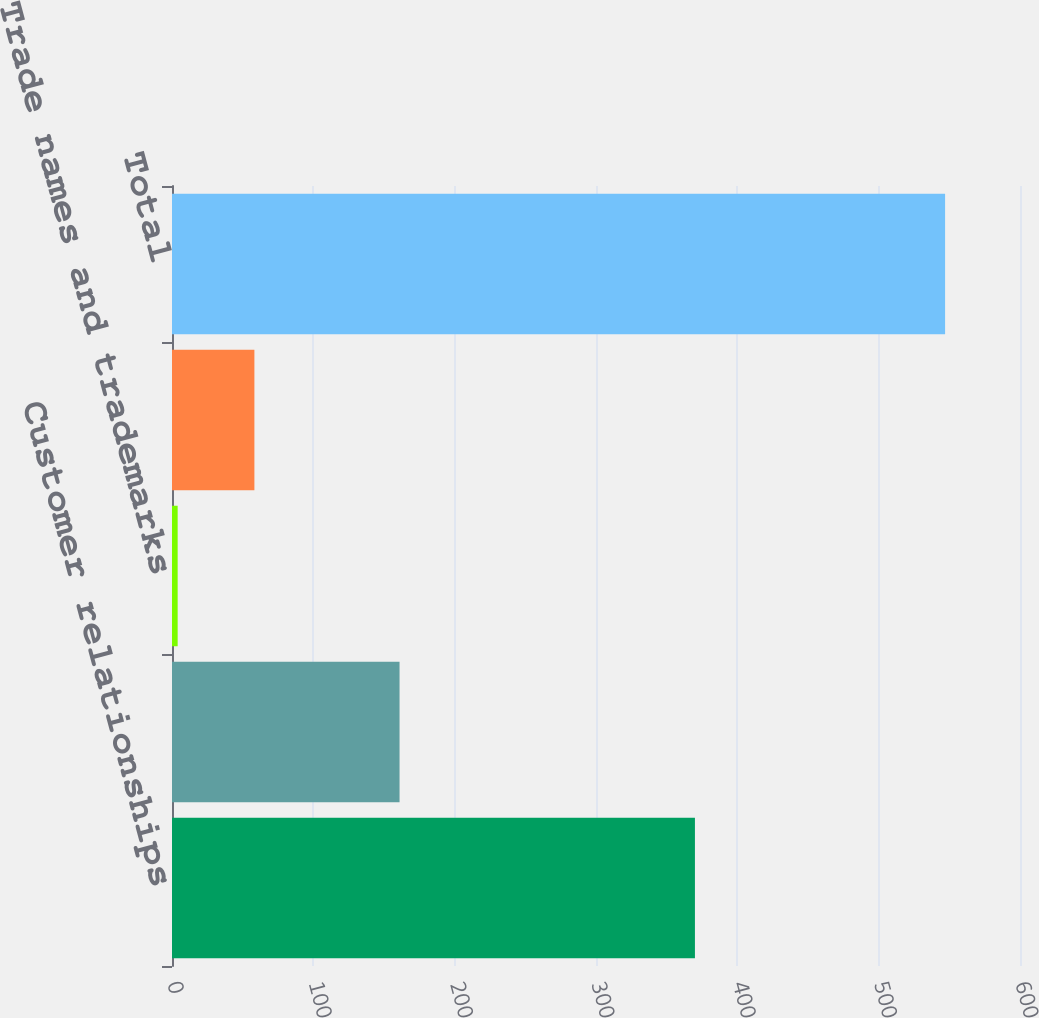Convert chart to OTSL. <chart><loc_0><loc_0><loc_500><loc_500><bar_chart><fcel>Customer relationships<fcel>Developed technology<fcel>Trade names and trademarks<fcel>Customer order backlog<fcel>Total<nl><fcel>370<fcel>161<fcel>4<fcel>58.3<fcel>547<nl></chart> 